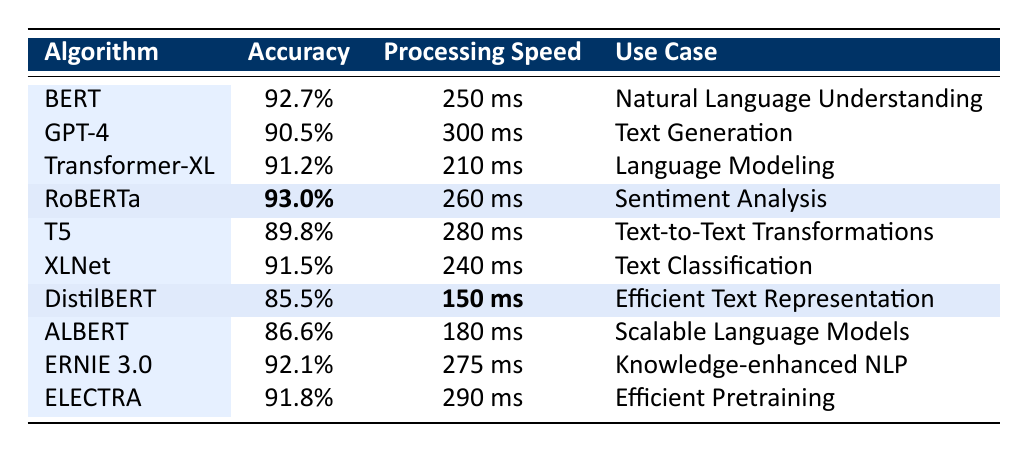What is the accuracy of RoBERTa? The table lists RoBERTa's accuracy in the second column, which shows it is 93.0%.
Answer: 93.0% Which algorithm has the highest accuracy? From the accuracy values presented in the table, RoBERTa has the highest accuracy at 93.0%, which is compared to all other algorithms listed.
Answer: RoBERTa What is the processing speed of DistilBERT? The processing speed for DistilBERT is found in the table under the third column, which indicates it is 150 ms per inference.
Answer: 150 ms Which algorithm is the fastest in terms of processing speed? Upon examining the processing speed column, DistilBERT has the lowest speed of 150 ms, indicating it is the fastest.
Answer: DistilBERT What is the average accuracy of all the algorithms listed? To find the average accuracy, first sum the accuracies (92.7 + 90.5 + 91.2 + 93.0 + 89.8 + 91.5 + 85.5 + 86.6 + 92.1 + 91.8 = 919.7), then divide by the number of algorithms (10), resulting in an average of 91.97%.
Answer: 91.97% Which algorithm has the lowest accuracy, and what is that accuracy? The table provides the accuracy data for each algorithm, identifying DistilBERT with the lowest accuracy at 85.5%.
Answer: DistilBERT, 85.5% Is there an algorithm with both high accuracy (over 90%) and low processing speed (under 250 ms)? After examining the table, Transformer-XL has an accuracy of 91.2% and a processing speed of 210 ms, meeting both criteria.
Answer: Yes, Transformer-XL What is the difference in processing speed between the fastest and slowest algorithms? The fastest algorithm is DistilBERT at 150 ms, and the slowest is GPT-4 at 300 ms. The difference is calculated as 300 ms - 150 ms = 150 ms.
Answer: 150 ms How many algorithms have an accuracy greater than 90%? Counting the algorithms from the table with accuracy above 90% (BERT, Transformer-XL, RoBERTa, ERNIE 3.0, and ELECTRA), there are a total of 5.
Answer: 5 Which use case is associated with the algorithm that has an accuracy of 89.8%? The algorithm with an accuracy of 89.8% is T5, which is used for Text-to-Text Transformations as provided in the table.
Answer: Text-to-Text Transformations Is the processing speed of GPT-4 faster than that of XLNet? The processing speeds from the table indicate GPT-4 (300 ms) is slower than XLNet (240 ms), so the answer is no.
Answer: No 